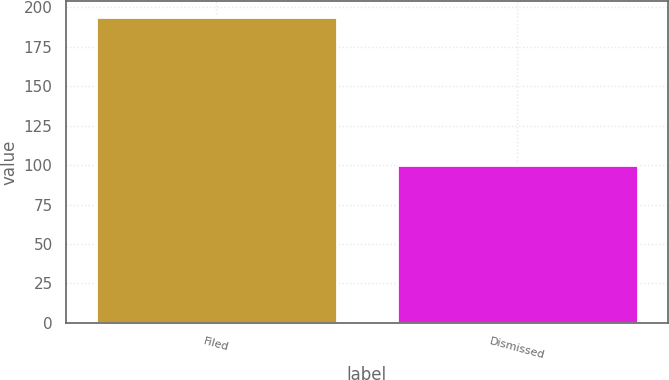<chart> <loc_0><loc_0><loc_500><loc_500><bar_chart><fcel>Filed<fcel>Dismissed<nl><fcel>194<fcel>100<nl></chart> 